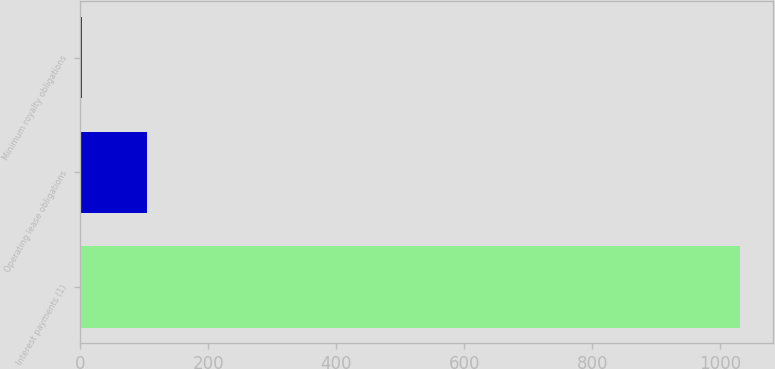<chart> <loc_0><loc_0><loc_500><loc_500><bar_chart><fcel>Interest payments (1)<fcel>Operating lease obligations<fcel>Minimum royalty obligations<nl><fcel>1030<fcel>104.8<fcel>2<nl></chart> 